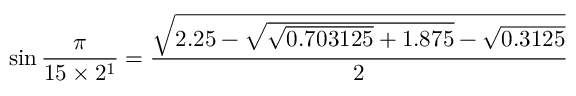<formula> <loc_0><loc_0><loc_500><loc_500>\sin { \frac { \pi } { 1 5 \times 2 ^ { 1 } } } = { \frac { \sqrt { 2 . 2 5 - { \sqrt { { \sqrt { 0 . 7 0 3 1 2 5 } } + 1 . 8 7 5 } } - { \sqrt { 0 . 3 1 2 5 } } } } { 2 } }</formula> 